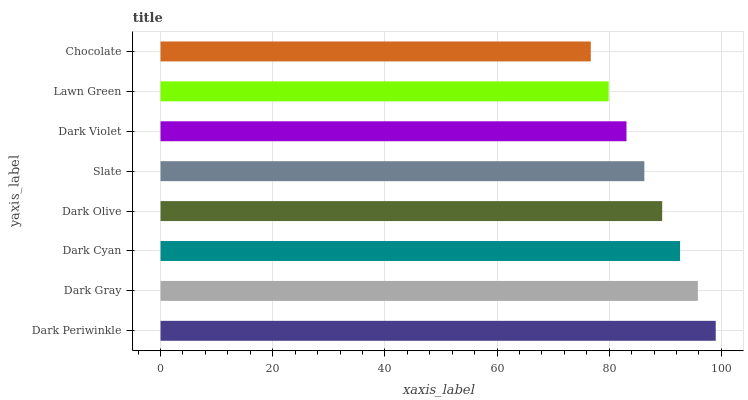Is Chocolate the minimum?
Answer yes or no. Yes. Is Dark Periwinkle the maximum?
Answer yes or no. Yes. Is Dark Gray the minimum?
Answer yes or no. No. Is Dark Gray the maximum?
Answer yes or no. No. Is Dark Periwinkle greater than Dark Gray?
Answer yes or no. Yes. Is Dark Gray less than Dark Periwinkle?
Answer yes or no. Yes. Is Dark Gray greater than Dark Periwinkle?
Answer yes or no. No. Is Dark Periwinkle less than Dark Gray?
Answer yes or no. No. Is Dark Olive the high median?
Answer yes or no. Yes. Is Slate the low median?
Answer yes or no. Yes. Is Lawn Green the high median?
Answer yes or no. No. Is Dark Violet the low median?
Answer yes or no. No. 